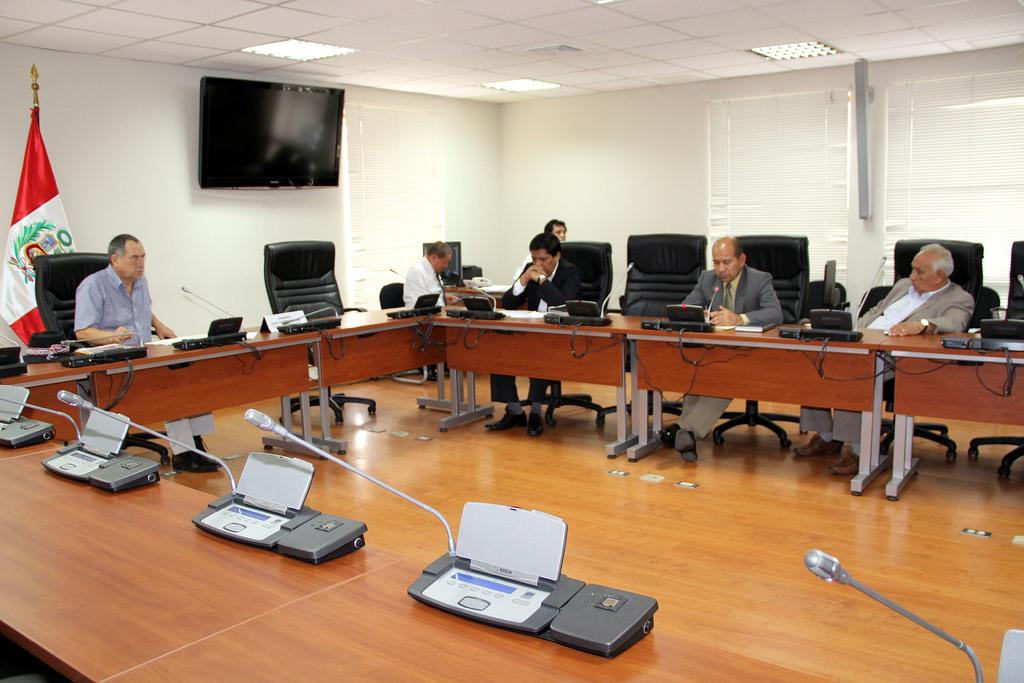What are the people in the image doing? The people in the image are sitting on chairs. What objects are on the table in the image? There are mics on the table in the image. What can be seen in the background of the image? There is a flag and a television on a wall in the background of the image. How many toes can be seen on the people in the image? There is no way to determine the number of toes on the people in the image, as their feet are not visible. 